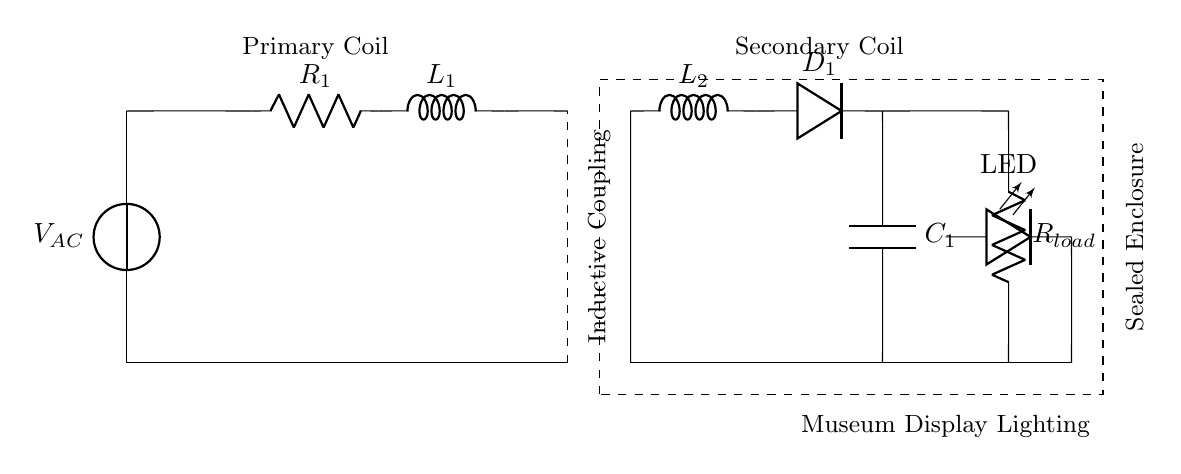What is the type of voltage source used in this circuit? The circuit uses an alternating current (AC) voltage source, as indicated by the symbol and the label V_AC.
Answer: AC What is the load in this circuit? The load component is R_load, which represents the resistor providing the load for the circuit.
Answer: Resistor How many coils are present in this inductive charging system? There are two coils present: the primary coil (L1) and the secondary coil (L2), as shown in the circuit diagram.
Answer: Two What component is used for rectification in the secondary side? The rectifier component used for rectification is D1, which allows current to flow in one direction to power the load and LED.
Answer: D1 What is the purpose of the sealed enclosure shown in the diagram? The sealed enclosure serves to protect the circuit from humidity and moisture in humid tropical conditions.
Answer: Humidity protection What frequency is expected for effective inductive charging? The circuit does not specify a frequency, but typical inductive charging systems operate within the frequency range of 20 kHz to a few MHz for optimal energy transfer.
Answer: Typical range What is the function of the capacitor C1 in the secondary circuit? Capacitor C1 acts to filter and smooth out the rectified voltage, providing stable voltage to the load and LED.
Answer: Smoothing 